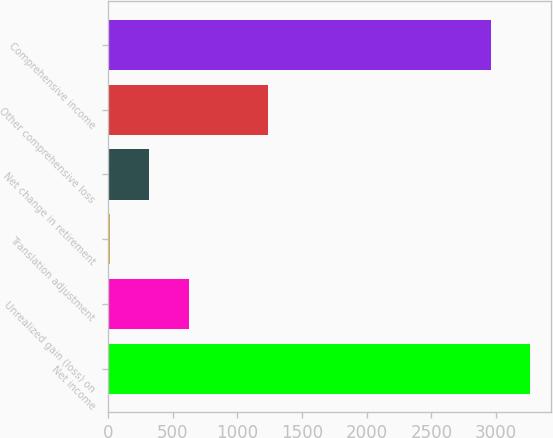<chart> <loc_0><loc_0><loc_500><loc_500><bar_chart><fcel>Net income<fcel>Unrealized gain (loss) on<fcel>Translation adjustment<fcel>Net change in retirement<fcel>Other comprehensive loss<fcel>Comprehensive income<nl><fcel>3265.2<fcel>623.4<fcel>13<fcel>318.2<fcel>1233.8<fcel>2960<nl></chart> 